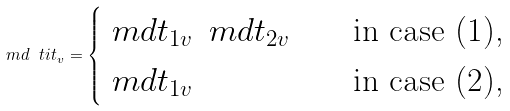<formula> <loc_0><loc_0><loc_500><loc_500>\ m d \ t i t _ { v } = \begin{cases} \ m d t _ { 1 v } \, \ m d t _ { 2 v } & \text {\quad in case (1),} \\ \ m d t _ { 1 v } & \text {\quad in case (2),} \end{cases}</formula> 